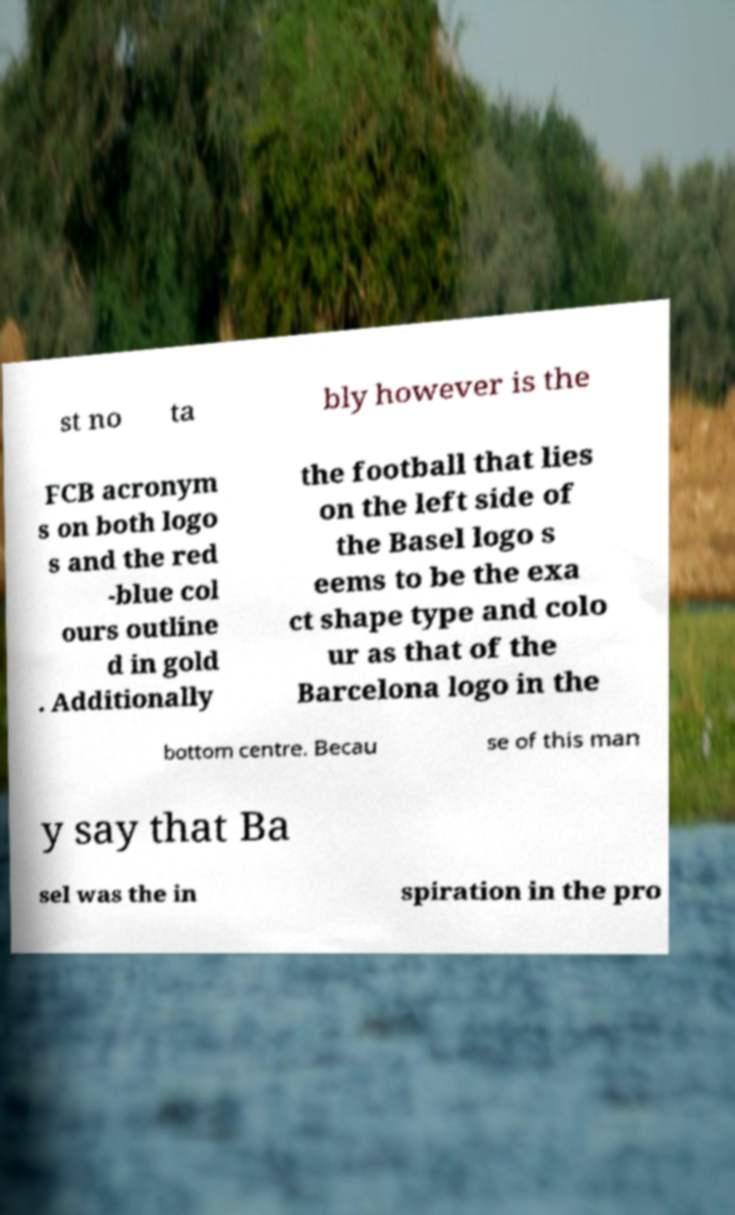Could you extract and type out the text from this image? st no ta bly however is the FCB acronym s on both logo s and the red -blue col ours outline d in gold . Additionally the football that lies on the left side of the Basel logo s eems to be the exa ct shape type and colo ur as that of the Barcelona logo in the bottom centre. Becau se of this man y say that Ba sel was the in spiration in the pro 